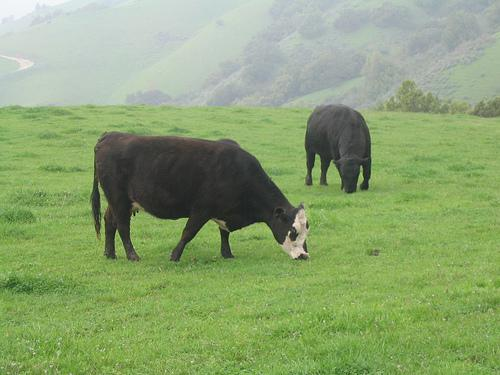Question: what animals are these?
Choices:
A. Horses.
B. Donkeys.
C. Dogs.
D. Cows.
Answer with the letter. Answer: D Question: what color are the cows?
Choices:
A. Black.
B. Blue.
C. Green.
D. Orange.
Answer with the letter. Answer: A Question: why is the cow's head down?
Choices:
A. It's smelling a flower.
B. It's drinking from a puddle.
C. It's sniffing the grass.
D. It's eating.
Answer with the letter. Answer: D Question: what are the cows eating?
Choices:
A. Grass.
B. Flowers.
C. Weeds.
D. Oats.
Answer with the letter. Answer: A 